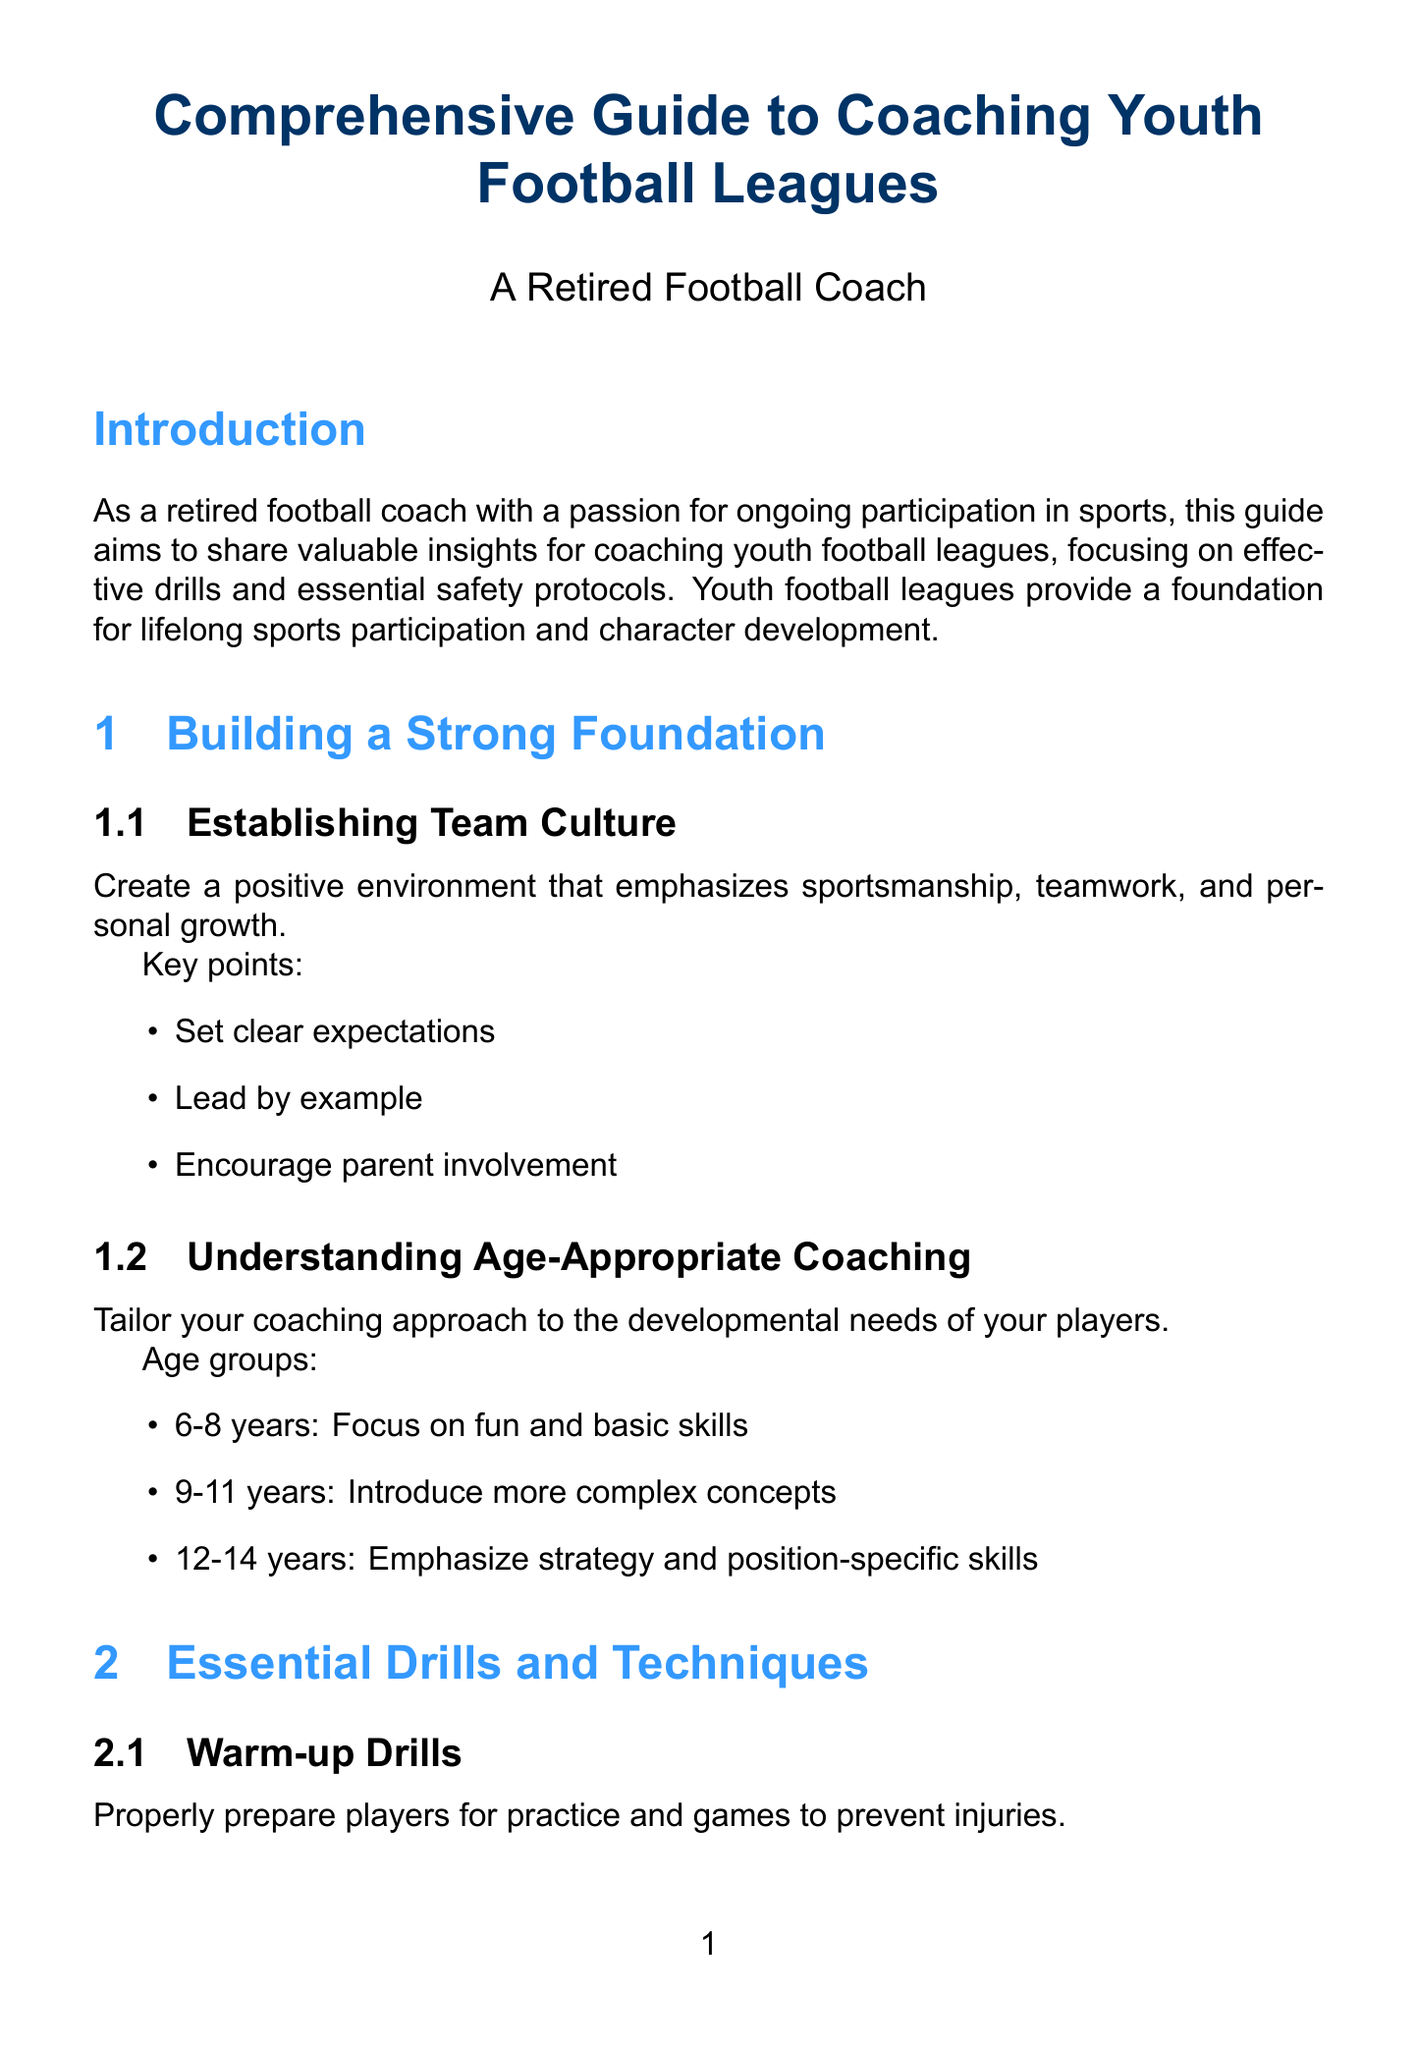What is the title of the guide? The title is mentioned at the beginning of the document and is "Comprehensive Guide to Coaching Youth Football Leagues."
Answer: Comprehensive Guide to Coaching Youth Football Leagues What age group is recommended to focus on fun and basic skills? The document specifies that for the age group of 6-8 years, the focus should be on fun and basic skills.
Answer: 6-8 years What is one key point for establishing team culture? A key point listed in the document emphasizes setting clear expectations.
Answer: Set clear expectations How many drills are listed under Offensive Drills? The document states there are two drills listed under Offensive Drills.
Answer: 2 What is the first item on the checklist for Equipment Safety? The checklist for Equipment Safety starts with helmet fitting and maintenance.
Answer: Helmet fitting and maintenance Which protocol should be implemented to protect players from concussions? The document suggests implementing a comprehensive concussion protocol to protect players.
Answer: Comprehensive concussion protocol What is one strategy to promote lifelong participation in sports? One strategy mentioned to encourage lifelong participation includes highlighting various football-related careers.
Answer: Highlight various football-related careers How often should water breaks be provided? The document states that water breaks should be provided every 15-20 minutes.
Answer: Every 15-20 minutes 